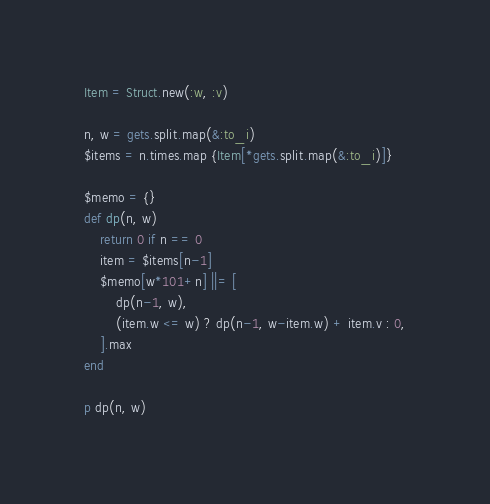<code> <loc_0><loc_0><loc_500><loc_500><_Ruby_>Item = Struct.new(:w, :v)

n, w = gets.split.map(&:to_i)
$items = n.times.map {Item[*gets.split.map(&:to_i)]}

$memo = {}
def dp(n, w)
	return 0 if n == 0
	item = $items[n-1]
	$memo[w*101+n] ||= [
		dp(n-1, w),
		(item.w <= w) ? dp(n-1, w-item.w) + item.v : 0,
	].max
end

p dp(n, w)
</code> 